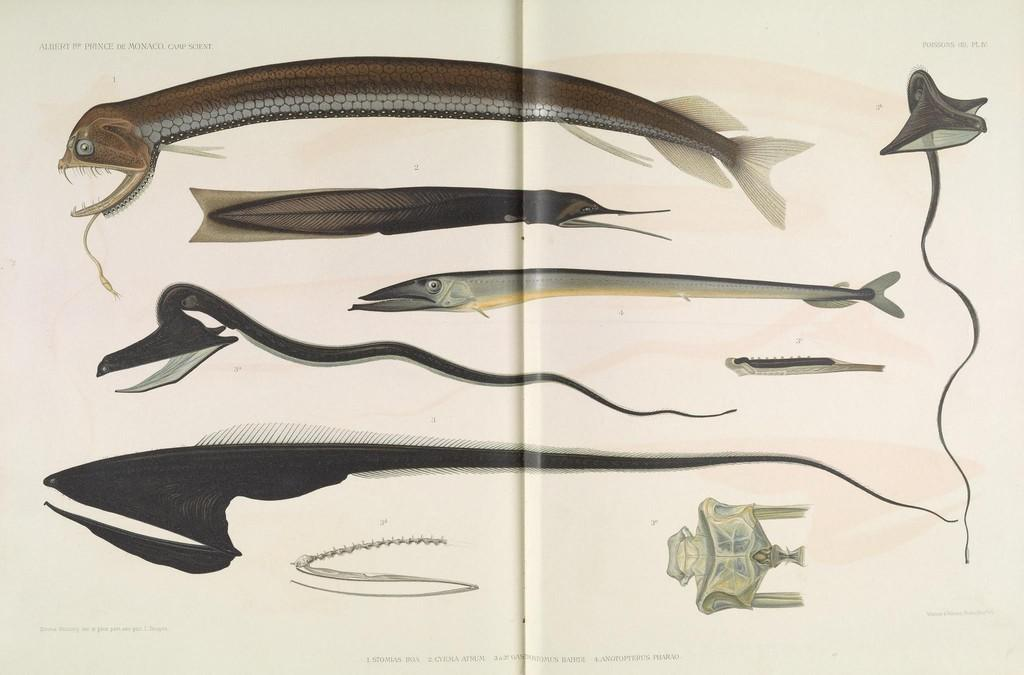What is present in the image? There is a poster in the image. What is depicted on the poster? The poster contains images of different types of fish. What is the price of the bedroom furniture in the image? There is no bedroom furniture present in the image, as it only contains a poster with images of fish. 